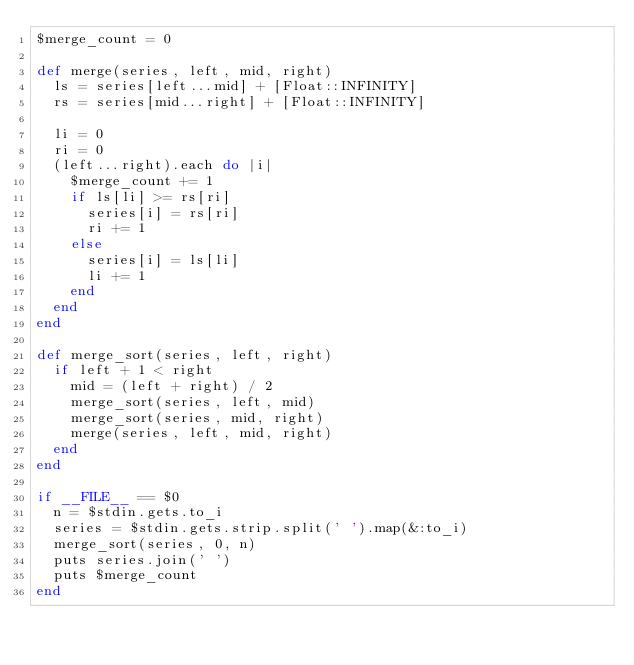Convert code to text. <code><loc_0><loc_0><loc_500><loc_500><_Ruby_>$merge_count = 0

def merge(series, left, mid, right)
  ls = series[left...mid] + [Float::INFINITY]
  rs = series[mid...right] + [Float::INFINITY]

  li = 0
  ri = 0
  (left...right).each do |i|
    $merge_count += 1
    if ls[li] >= rs[ri]
      series[i] = rs[ri]
      ri += 1
    else
      series[i] = ls[li]
      li += 1
    end
  end
end

def merge_sort(series, left, right)
  if left + 1 < right
    mid = (left + right) / 2
    merge_sort(series, left, mid)
    merge_sort(series, mid, right)
    merge(series, left, mid, right)
  end
end

if __FILE__ == $0
  n = $stdin.gets.to_i
  series = $stdin.gets.strip.split(' ').map(&:to_i)
  merge_sort(series, 0, n)
  puts series.join(' ')
  puts $merge_count
end
</code> 